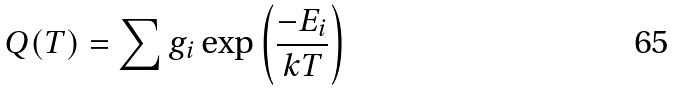Convert formula to latex. <formula><loc_0><loc_0><loc_500><loc_500>Q ( T ) = \sum g _ { i } \exp \left ( \frac { - E _ { i } } { k T } \right )</formula> 